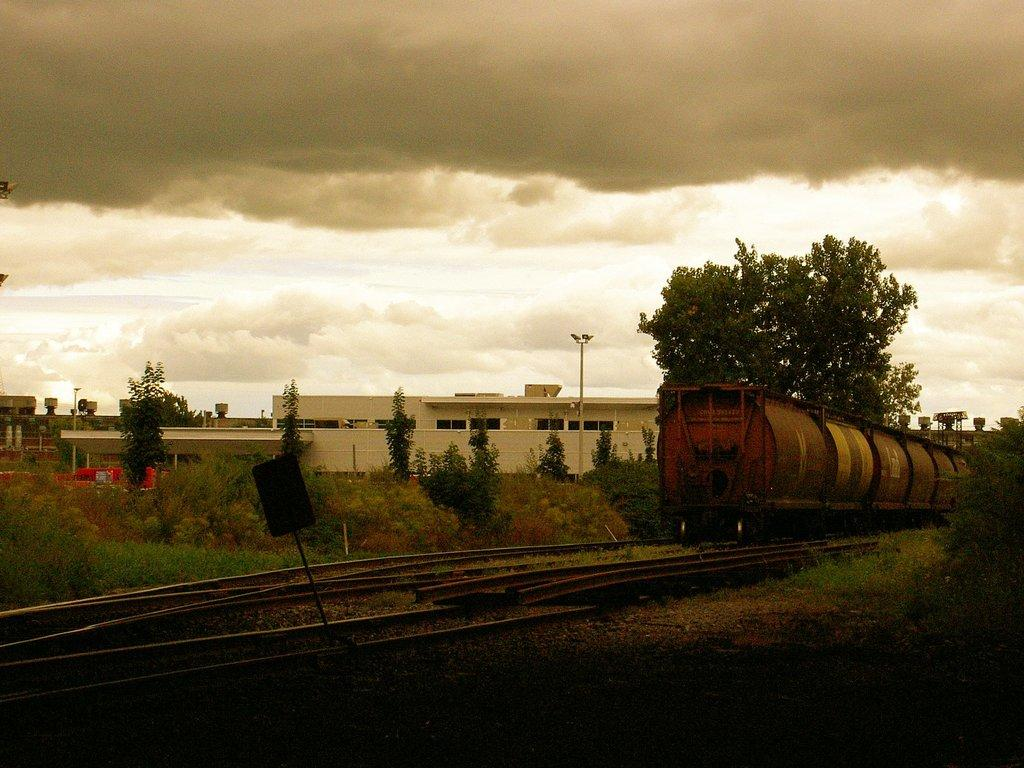What is the main subject of the image? The main subject of the image is a train. What is the train doing in the image? The train is moving on a railway track. What can be seen in the background of the image? There are houses and trees around the train. What type of plants can be seen growing on the train in the image? There are no plants growing on the train in the image. 